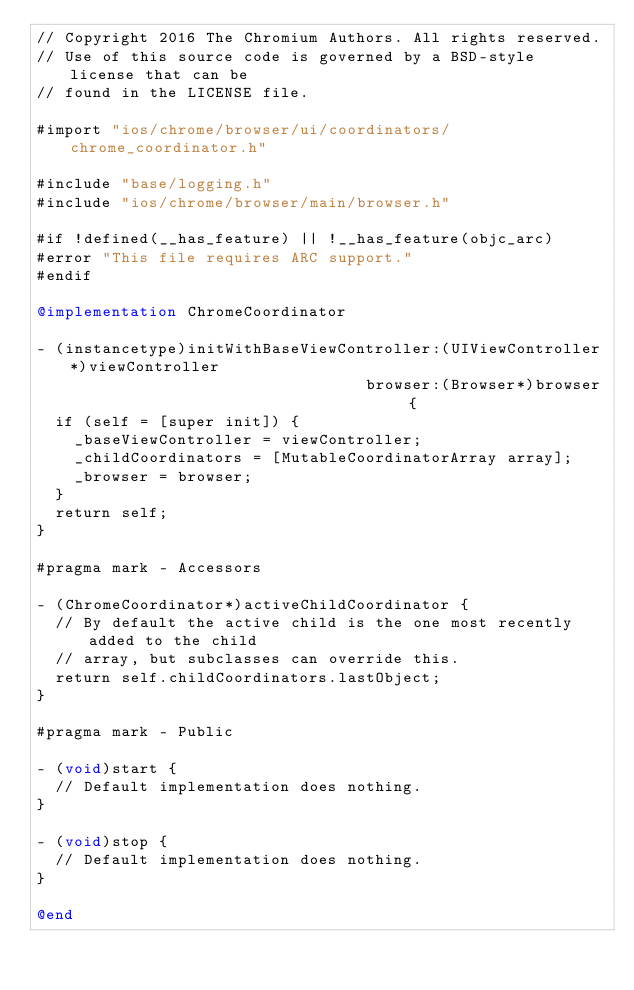Convert code to text. <code><loc_0><loc_0><loc_500><loc_500><_ObjectiveC_>// Copyright 2016 The Chromium Authors. All rights reserved.
// Use of this source code is governed by a BSD-style license that can be
// found in the LICENSE file.

#import "ios/chrome/browser/ui/coordinators/chrome_coordinator.h"

#include "base/logging.h"
#include "ios/chrome/browser/main/browser.h"

#if !defined(__has_feature) || !__has_feature(objc_arc)
#error "This file requires ARC support."
#endif

@implementation ChromeCoordinator

- (instancetype)initWithBaseViewController:(UIViewController*)viewController
                                   browser:(Browser*)browser {
  if (self = [super init]) {
    _baseViewController = viewController;
    _childCoordinators = [MutableCoordinatorArray array];
    _browser = browser;
  }
  return self;
}

#pragma mark - Accessors

- (ChromeCoordinator*)activeChildCoordinator {
  // By default the active child is the one most recently added to the child
  // array, but subclasses can override this.
  return self.childCoordinators.lastObject;
}

#pragma mark - Public

- (void)start {
  // Default implementation does nothing.
}

- (void)stop {
  // Default implementation does nothing.
}

@end
</code> 